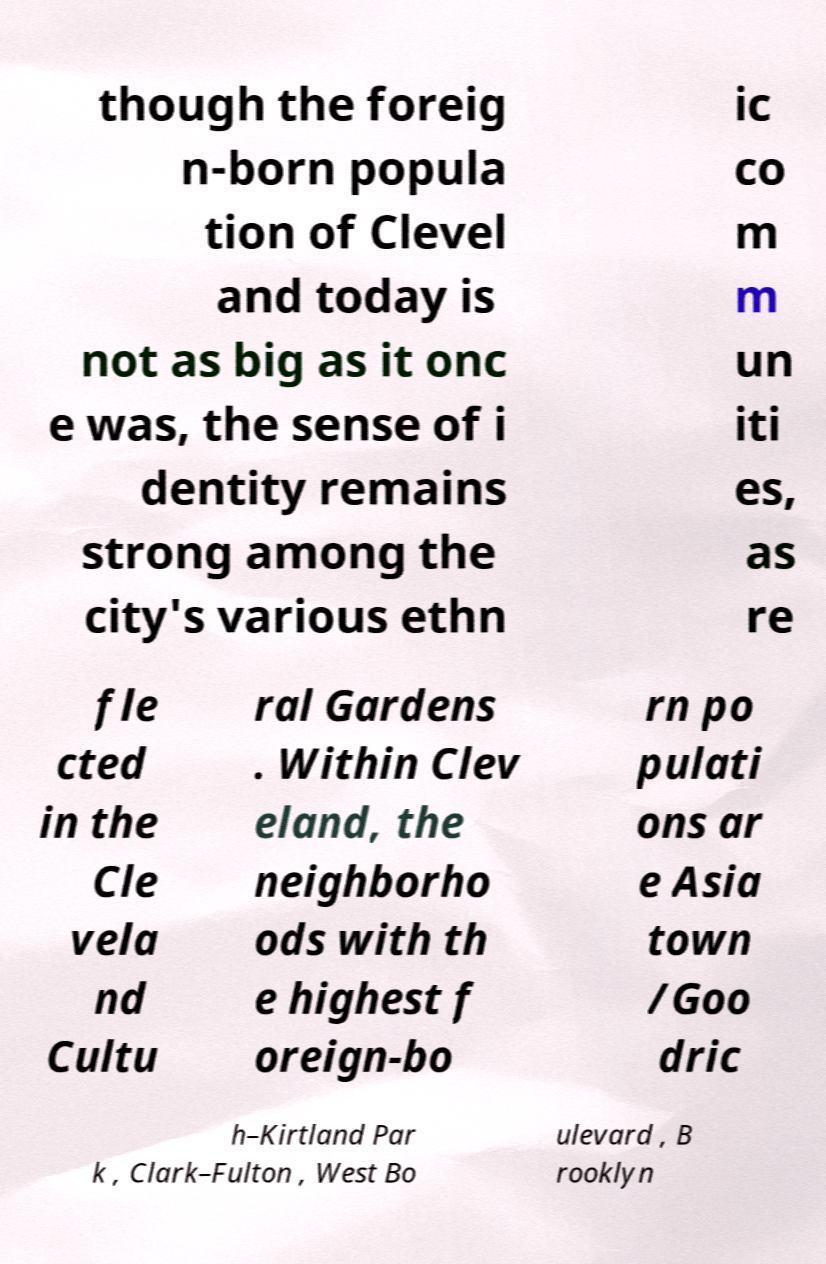I need the written content from this picture converted into text. Can you do that? though the foreig n-born popula tion of Clevel and today is not as big as it onc e was, the sense of i dentity remains strong among the city's various ethn ic co m m un iti es, as re fle cted in the Cle vela nd Cultu ral Gardens . Within Clev eland, the neighborho ods with th e highest f oreign-bo rn po pulati ons ar e Asia town /Goo dric h–Kirtland Par k , Clark–Fulton , West Bo ulevard , B rooklyn 